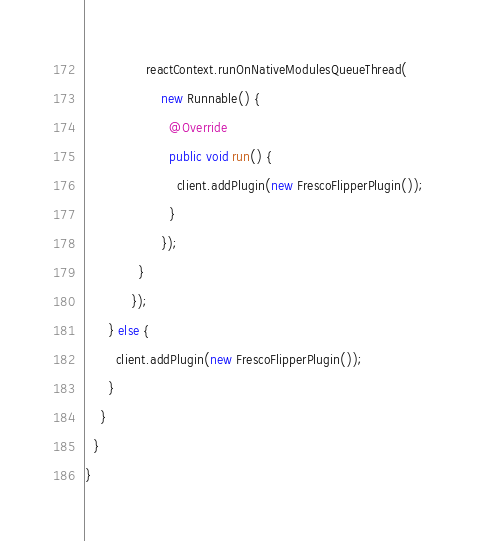<code> <loc_0><loc_0><loc_500><loc_500><_Java_>                reactContext.runOnNativeModulesQueueThread(
                    new Runnable() {
                      @Override
                      public void run() {
                        client.addPlugin(new FrescoFlipperPlugin());
                      }
                    });
              }
            });
      } else {
        client.addPlugin(new FrescoFlipperPlugin());
      }
    }
  }
}
</code> 